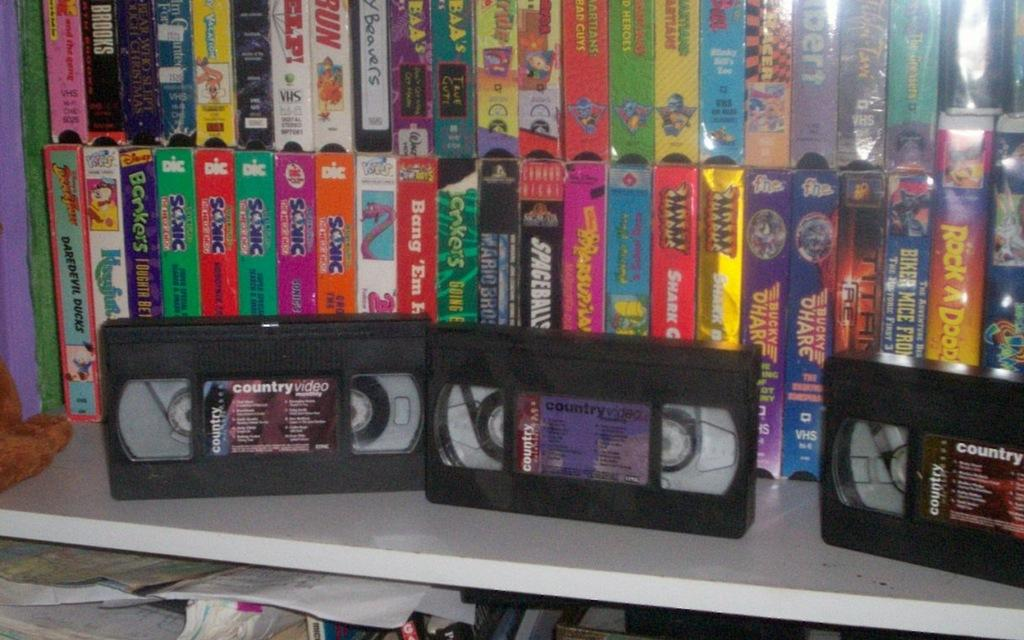<image>
Give a short and clear explanation of the subsequent image. a large collection of VHS tapes includes spaceballs 